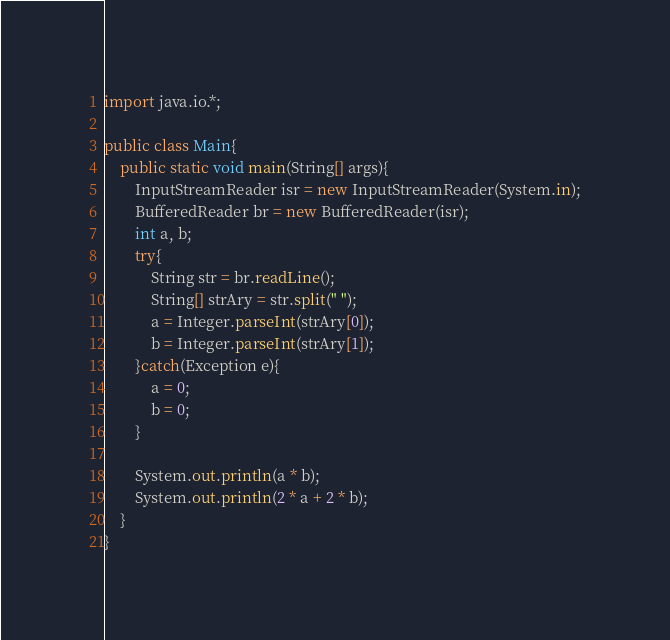Convert code to text. <code><loc_0><loc_0><loc_500><loc_500><_Java_>import java.io.*;

public class Main{
	public static void main(String[] args){
		InputStreamReader isr = new InputStreamReader(System.in);
		BufferedReader br = new BufferedReader(isr);
		int a, b;
		try{
			String str = br.readLine();
			String[] strAry = str.split(" ");
			a = Integer.parseInt(strAry[0]);
			b = Integer.parseInt(strAry[1]);
		}catch(Exception e){
			a = 0;
			b = 0;
		}

		System.out.println(a * b);
		System.out.println(2 * a + 2 * b);
	}
}</code> 